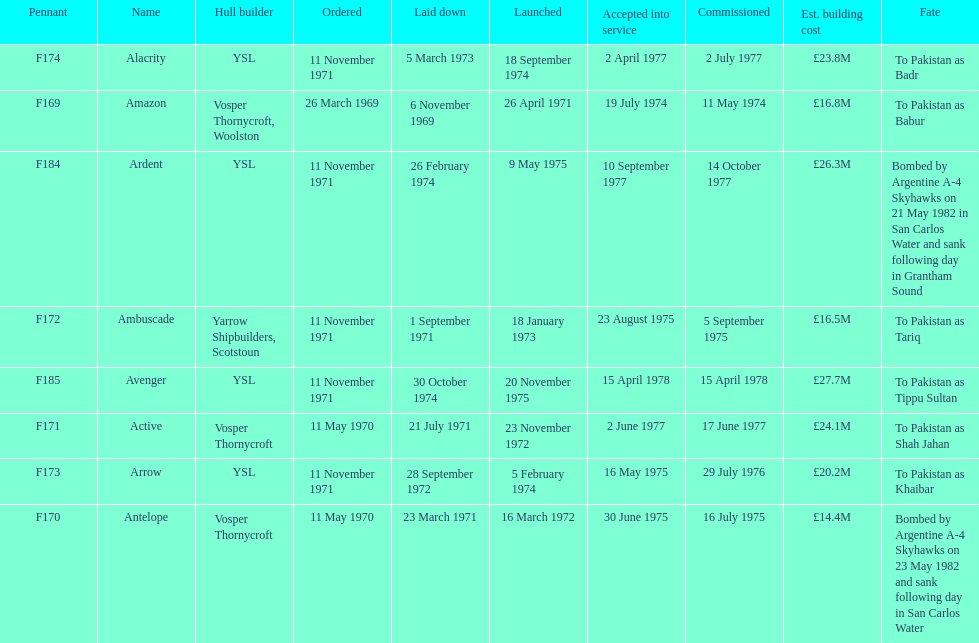Which ship had the highest estimated cost to build? Avenger. 